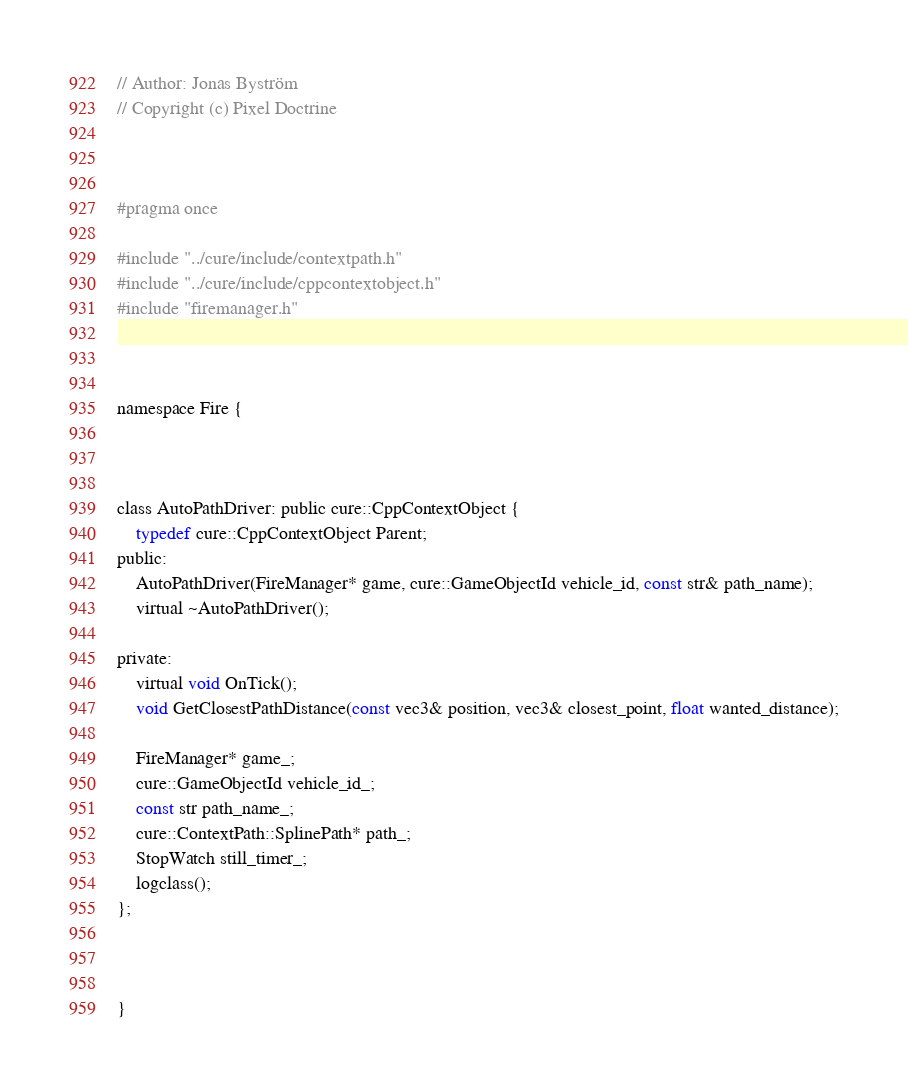<code> <loc_0><loc_0><loc_500><loc_500><_C_>
// Author: Jonas Byström
// Copyright (c) Pixel Doctrine



#pragma once

#include "../cure/include/contextpath.h"
#include "../cure/include/cppcontextobject.h"
#include "firemanager.h"



namespace Fire {



class AutoPathDriver: public cure::CppContextObject {
	typedef cure::CppContextObject Parent;
public:
	AutoPathDriver(FireManager* game, cure::GameObjectId vehicle_id, const str& path_name);
	virtual ~AutoPathDriver();

private:
	virtual void OnTick();
	void GetClosestPathDistance(const vec3& position, vec3& closest_point, float wanted_distance);

	FireManager* game_;
	cure::GameObjectId vehicle_id_;
	const str path_name_;
	cure::ContextPath::SplinePath* path_;
	StopWatch still_timer_;
	logclass();
};



}
</code> 